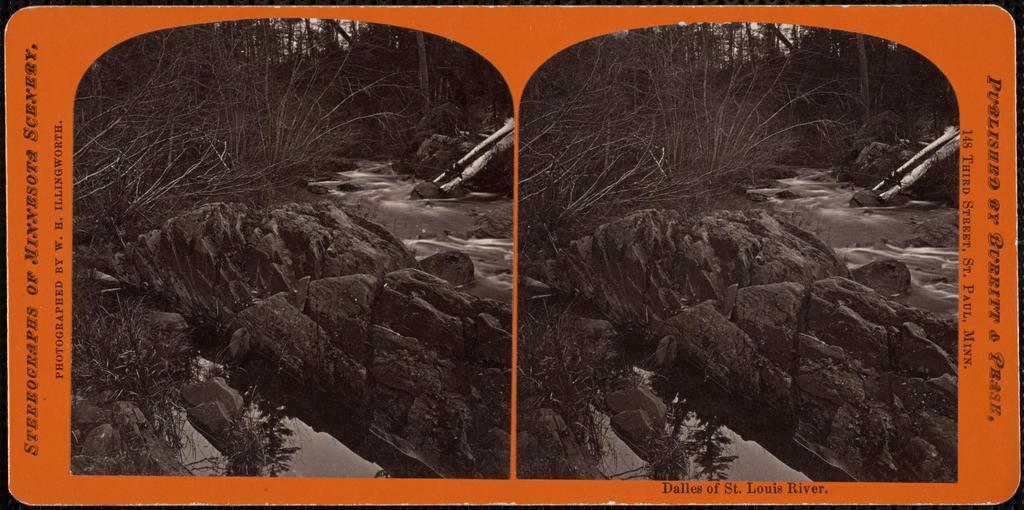In one or two sentences, can you explain what this image depicts? I see this is a collage image and I see rocks, trees and I see the water and I can also see the orange color thing on which there are words written. 